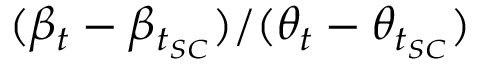<formula> <loc_0><loc_0><loc_500><loc_500>( \beta _ { t } - \beta _ { t _ { S C } } ) / ( \theta _ { t } - \theta _ { t _ { S C } } )</formula> 